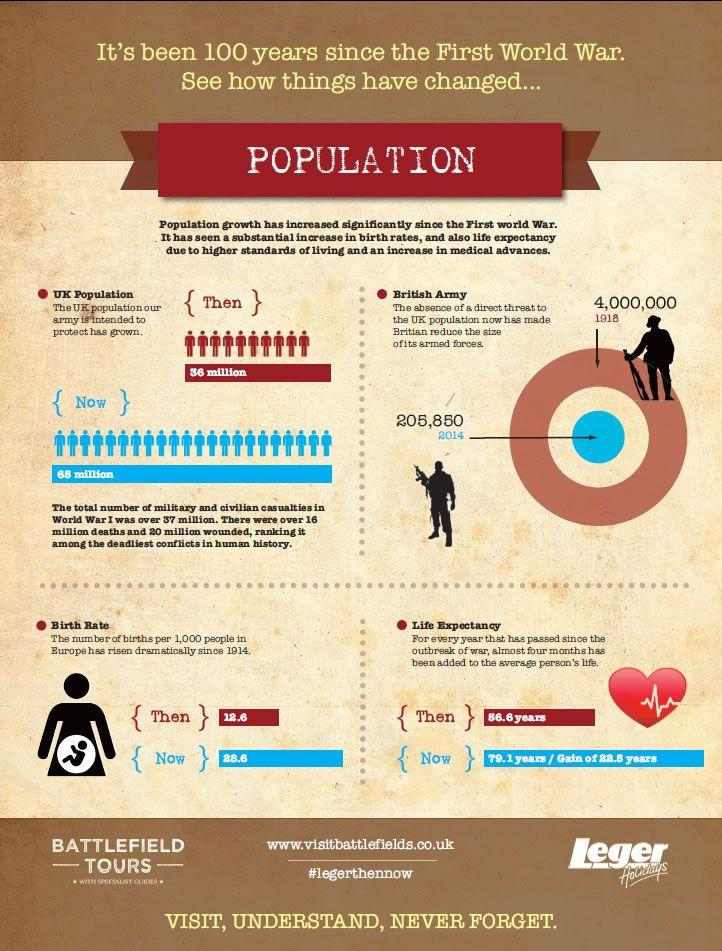Identify some key points in this picture. The birth rate in the United Kingdom in 2014 was 28.6. In 1918, the number of British armed forces was approximately 4,000,000. In 1918, the life expectancy in the UK was 56.6 years. 